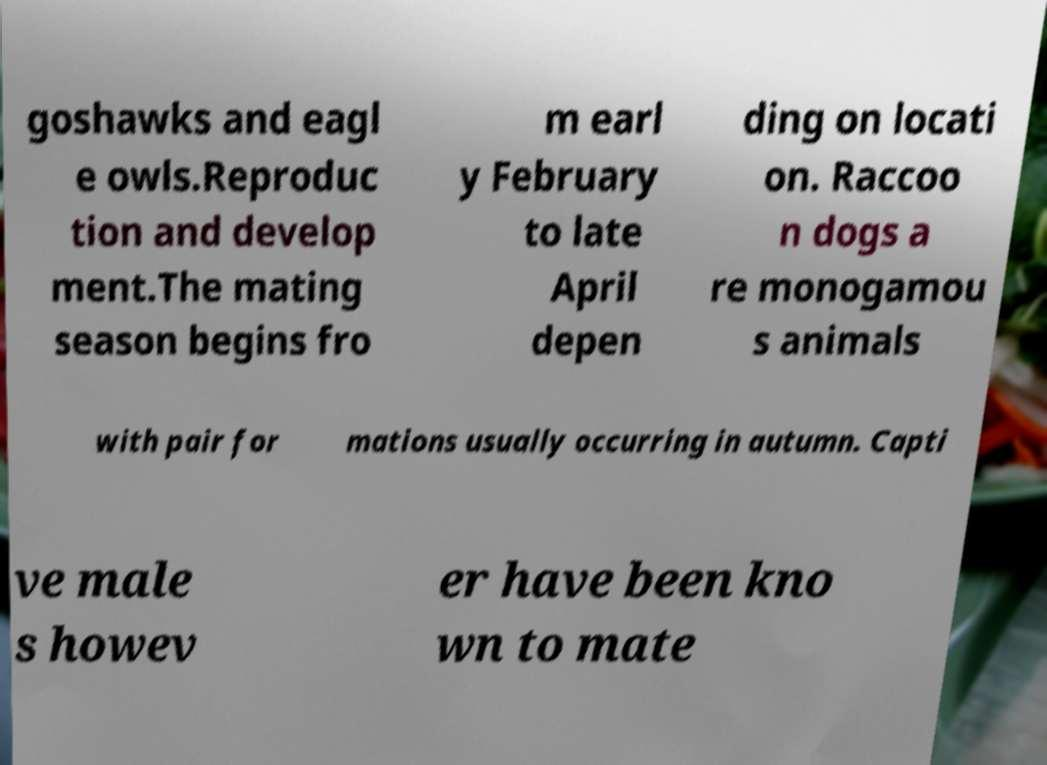Could you assist in decoding the text presented in this image and type it out clearly? goshawks and eagl e owls.Reproduc tion and develop ment.The mating season begins fro m earl y February to late April depen ding on locati on. Raccoo n dogs a re monogamou s animals with pair for mations usually occurring in autumn. Capti ve male s howev er have been kno wn to mate 